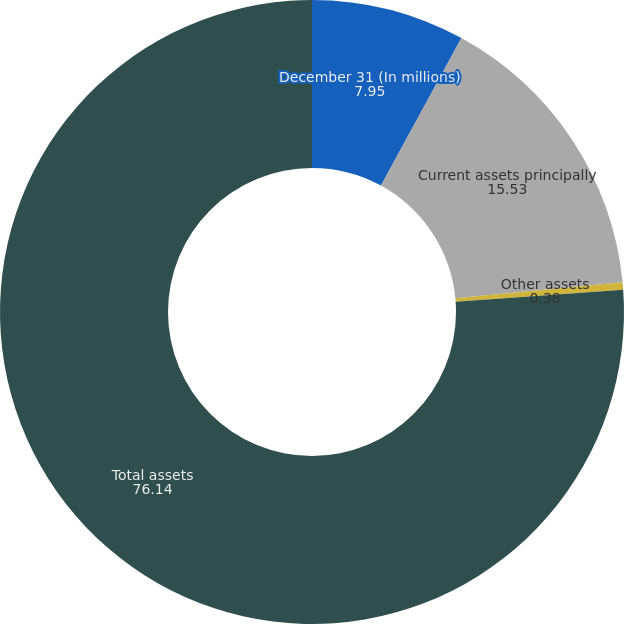Convert chart. <chart><loc_0><loc_0><loc_500><loc_500><pie_chart><fcel>December 31 (In millions)<fcel>Current assets principally<fcel>Other assets<fcel>Total assets<nl><fcel>7.95%<fcel>15.53%<fcel>0.38%<fcel>76.14%<nl></chart> 